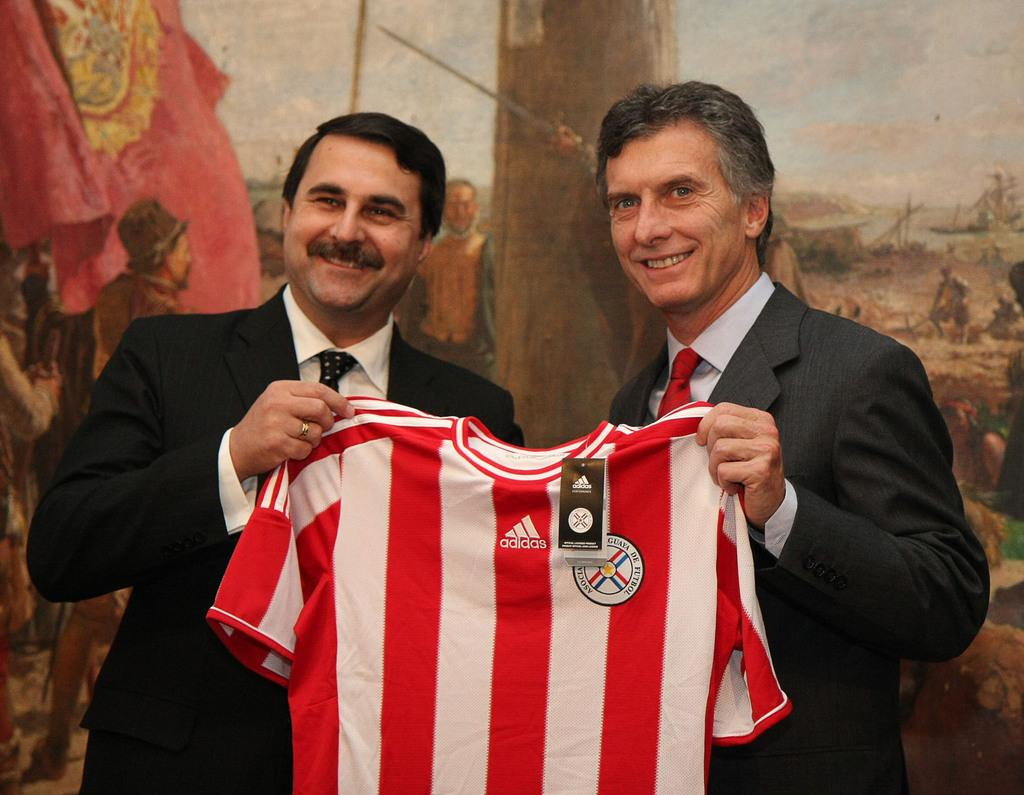<image>
Write a terse but informative summary of the picture. Two men are holding a red and white Adidas shirt. 